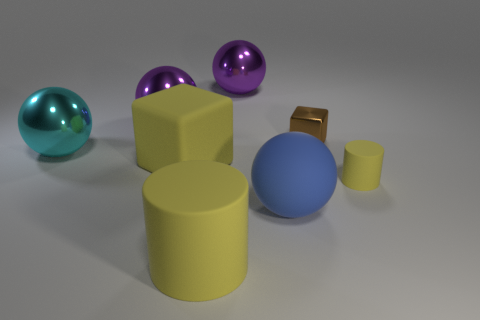Subtract all yellow cylinders. How many were subtracted if there are1yellow cylinders left? 1 Subtract 0 blue cylinders. How many objects are left? 8 Subtract 1 blocks. How many blocks are left? 1 Subtract all blue balls. Subtract all blue cylinders. How many balls are left? 3 Subtract all brown cylinders. How many green cubes are left? 0 Subtract all cyan things. Subtract all large cyan shiny things. How many objects are left? 6 Add 6 large yellow things. How many large yellow things are left? 8 Add 7 tiny yellow cylinders. How many tiny yellow cylinders exist? 8 Add 2 large blue objects. How many objects exist? 10 Subtract all brown cubes. How many cubes are left? 1 